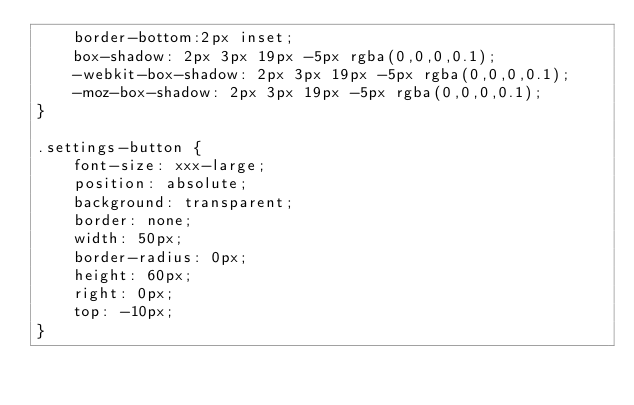Convert code to text. <code><loc_0><loc_0><loc_500><loc_500><_CSS_>    border-bottom:2px inset;
    box-shadow: 2px 3px 19px -5px rgba(0,0,0,0.1);
    -webkit-box-shadow: 2px 3px 19px -5px rgba(0,0,0,0.1);
    -moz-box-shadow: 2px 3px 19px -5px rgba(0,0,0,0.1);
}

.settings-button {
    font-size: xxx-large;
    position: absolute;
    background: transparent;
    border: none;
    width: 50px;
    border-radius: 0px;
    height: 60px;
    right: 0px;
    top: -10px;
}</code> 